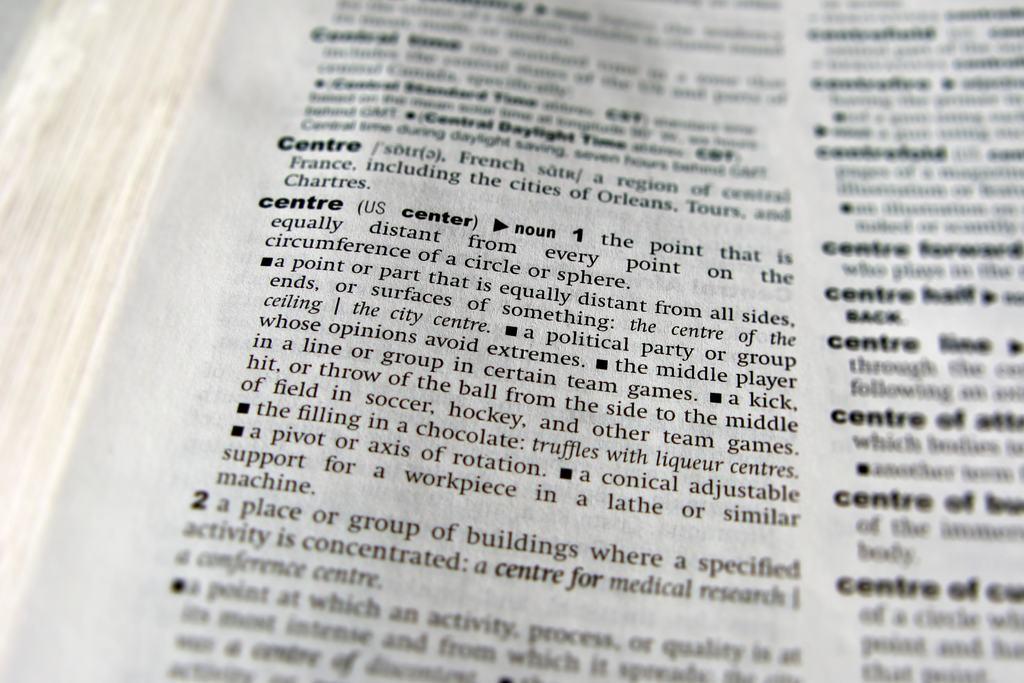Which number is on the left of the page?
Make the answer very short. 2. 